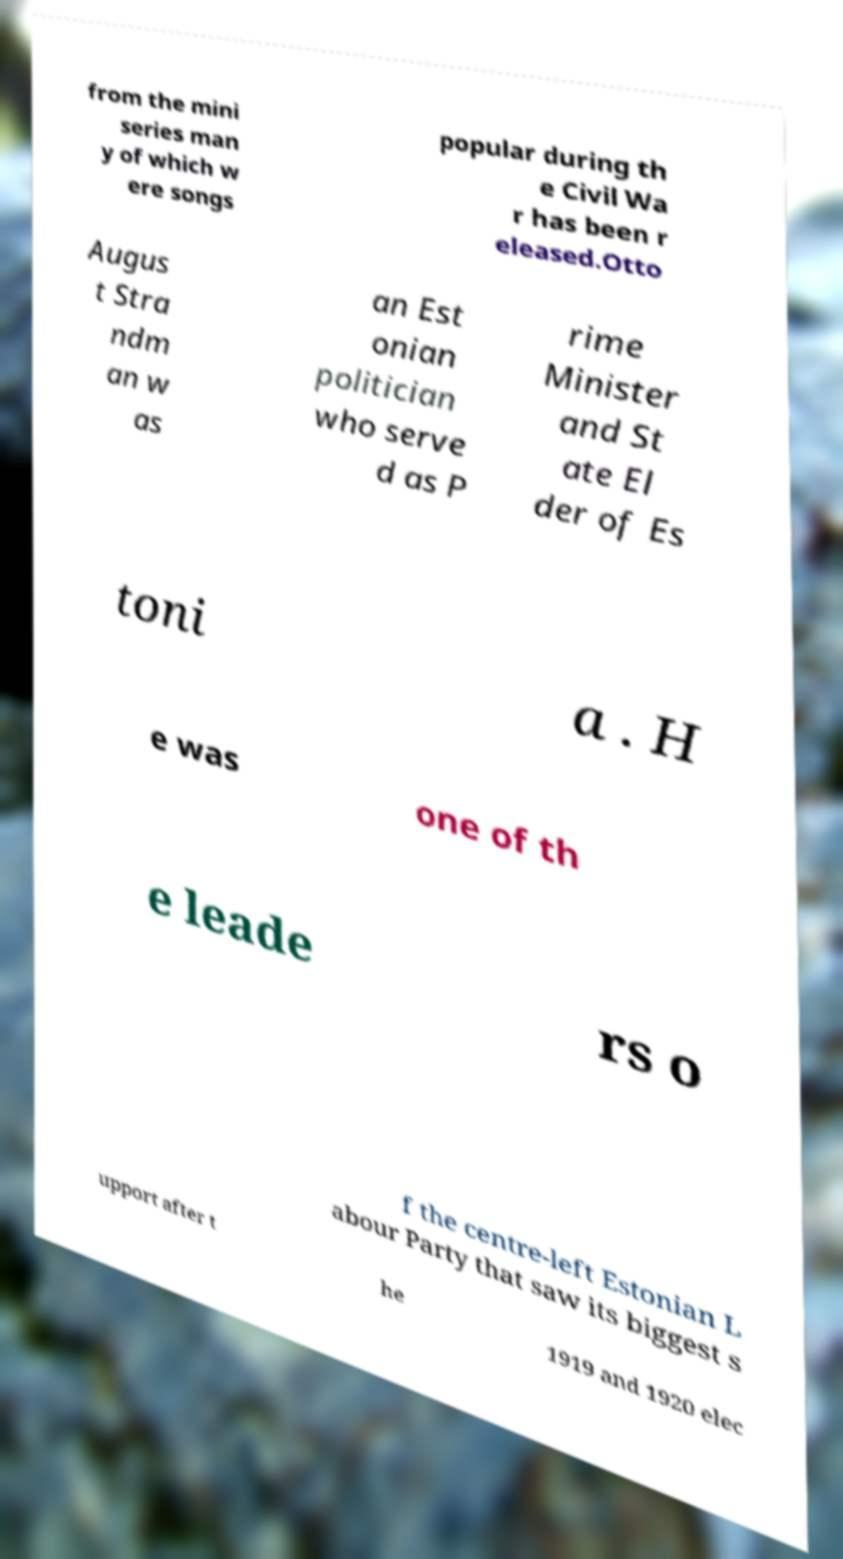Please read and relay the text visible in this image. What does it say? from the mini series man y of which w ere songs popular during th e Civil Wa r has been r eleased.Otto Augus t Stra ndm an w as an Est onian politician who serve d as P rime Minister and St ate El der of Es toni a . H e was one of th e leade rs o f the centre-left Estonian L abour Party that saw its biggest s upport after t he 1919 and 1920 elec 